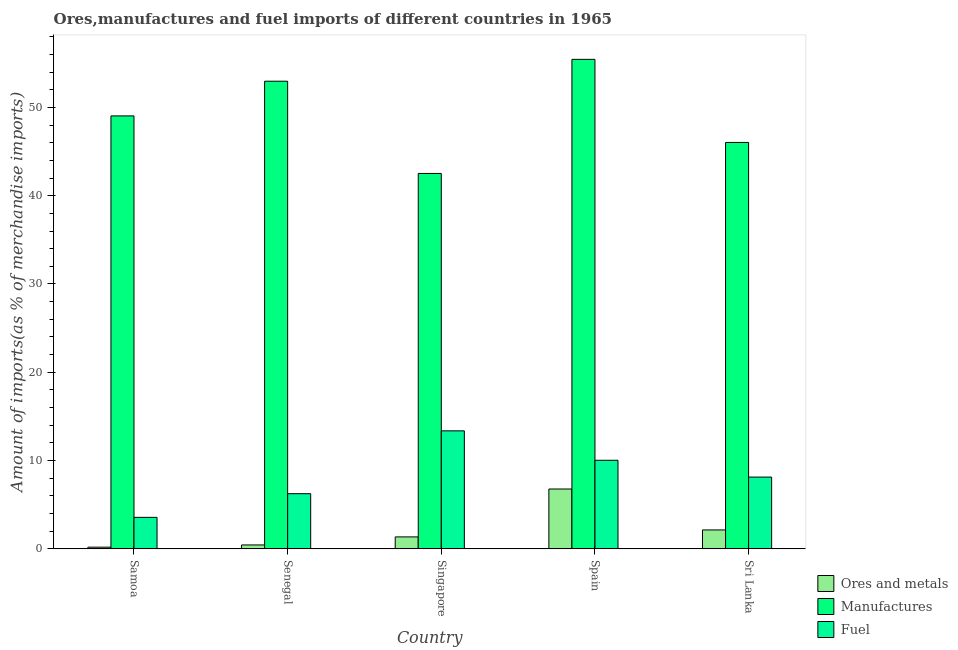How many groups of bars are there?
Provide a short and direct response. 5. Are the number of bars per tick equal to the number of legend labels?
Provide a succinct answer. Yes. How many bars are there on the 1st tick from the left?
Your answer should be compact. 3. How many bars are there on the 4th tick from the right?
Offer a very short reply. 3. What is the label of the 3rd group of bars from the left?
Provide a short and direct response. Singapore. In how many cases, is the number of bars for a given country not equal to the number of legend labels?
Ensure brevity in your answer.  0. What is the percentage of fuel imports in Singapore?
Your response must be concise. 13.37. Across all countries, what is the maximum percentage of ores and metals imports?
Keep it short and to the point. 6.78. Across all countries, what is the minimum percentage of ores and metals imports?
Your answer should be very brief. 0.19. In which country was the percentage of fuel imports maximum?
Provide a succinct answer. Singapore. In which country was the percentage of ores and metals imports minimum?
Your answer should be very brief. Samoa. What is the total percentage of manufactures imports in the graph?
Your response must be concise. 246.01. What is the difference between the percentage of manufactures imports in Spain and that in Sri Lanka?
Your answer should be very brief. 9.41. What is the difference between the percentage of manufactures imports in Senegal and the percentage of fuel imports in Spain?
Keep it short and to the point. 42.94. What is the average percentage of manufactures imports per country?
Offer a very short reply. 49.2. What is the difference between the percentage of fuel imports and percentage of ores and metals imports in Sri Lanka?
Give a very brief answer. 5.99. In how many countries, is the percentage of manufactures imports greater than 42 %?
Offer a very short reply. 5. What is the ratio of the percentage of ores and metals imports in Samoa to that in Senegal?
Keep it short and to the point. 0.43. Is the percentage of fuel imports in Samoa less than that in Spain?
Your response must be concise. Yes. What is the difference between the highest and the second highest percentage of fuel imports?
Your answer should be very brief. 3.33. What is the difference between the highest and the lowest percentage of manufactures imports?
Your answer should be very brief. 12.92. What does the 3rd bar from the left in Singapore represents?
Ensure brevity in your answer.  Fuel. What does the 1st bar from the right in Sri Lanka represents?
Keep it short and to the point. Fuel. Is it the case that in every country, the sum of the percentage of ores and metals imports and percentage of manufactures imports is greater than the percentage of fuel imports?
Give a very brief answer. Yes. What is the difference between two consecutive major ticks on the Y-axis?
Offer a very short reply. 10. Are the values on the major ticks of Y-axis written in scientific E-notation?
Offer a terse response. No. Does the graph contain any zero values?
Your response must be concise. No. Does the graph contain grids?
Offer a terse response. No. How are the legend labels stacked?
Ensure brevity in your answer.  Vertical. What is the title of the graph?
Provide a short and direct response. Ores,manufactures and fuel imports of different countries in 1965. What is the label or title of the Y-axis?
Offer a very short reply. Amount of imports(as % of merchandise imports). What is the Amount of imports(as % of merchandise imports) of Ores and metals in Samoa?
Offer a terse response. 0.19. What is the Amount of imports(as % of merchandise imports) of Manufactures in Samoa?
Ensure brevity in your answer.  49.04. What is the Amount of imports(as % of merchandise imports) in Fuel in Samoa?
Your answer should be compact. 3.57. What is the Amount of imports(as % of merchandise imports) in Ores and metals in Senegal?
Provide a short and direct response. 0.44. What is the Amount of imports(as % of merchandise imports) in Manufactures in Senegal?
Provide a succinct answer. 52.97. What is the Amount of imports(as % of merchandise imports) in Fuel in Senegal?
Your answer should be very brief. 6.25. What is the Amount of imports(as % of merchandise imports) of Ores and metals in Singapore?
Offer a very short reply. 1.35. What is the Amount of imports(as % of merchandise imports) of Manufactures in Singapore?
Your response must be concise. 42.52. What is the Amount of imports(as % of merchandise imports) of Fuel in Singapore?
Your response must be concise. 13.37. What is the Amount of imports(as % of merchandise imports) in Ores and metals in Spain?
Your answer should be very brief. 6.78. What is the Amount of imports(as % of merchandise imports) of Manufactures in Spain?
Ensure brevity in your answer.  55.44. What is the Amount of imports(as % of merchandise imports) of Fuel in Spain?
Provide a short and direct response. 10.03. What is the Amount of imports(as % of merchandise imports) of Ores and metals in Sri Lanka?
Provide a short and direct response. 2.14. What is the Amount of imports(as % of merchandise imports) of Manufactures in Sri Lanka?
Offer a terse response. 46.03. What is the Amount of imports(as % of merchandise imports) in Fuel in Sri Lanka?
Keep it short and to the point. 8.13. Across all countries, what is the maximum Amount of imports(as % of merchandise imports) of Ores and metals?
Make the answer very short. 6.78. Across all countries, what is the maximum Amount of imports(as % of merchandise imports) of Manufactures?
Offer a terse response. 55.44. Across all countries, what is the maximum Amount of imports(as % of merchandise imports) in Fuel?
Keep it short and to the point. 13.37. Across all countries, what is the minimum Amount of imports(as % of merchandise imports) in Ores and metals?
Ensure brevity in your answer.  0.19. Across all countries, what is the minimum Amount of imports(as % of merchandise imports) in Manufactures?
Your answer should be very brief. 42.52. Across all countries, what is the minimum Amount of imports(as % of merchandise imports) of Fuel?
Give a very brief answer. 3.57. What is the total Amount of imports(as % of merchandise imports) in Ores and metals in the graph?
Offer a very short reply. 10.91. What is the total Amount of imports(as % of merchandise imports) of Manufactures in the graph?
Your response must be concise. 246.01. What is the total Amount of imports(as % of merchandise imports) in Fuel in the graph?
Your answer should be compact. 41.34. What is the difference between the Amount of imports(as % of merchandise imports) of Ores and metals in Samoa and that in Senegal?
Your response must be concise. -0.25. What is the difference between the Amount of imports(as % of merchandise imports) of Manufactures in Samoa and that in Senegal?
Make the answer very short. -3.93. What is the difference between the Amount of imports(as % of merchandise imports) of Fuel in Samoa and that in Senegal?
Offer a terse response. -2.68. What is the difference between the Amount of imports(as % of merchandise imports) of Ores and metals in Samoa and that in Singapore?
Give a very brief answer. -1.16. What is the difference between the Amount of imports(as % of merchandise imports) of Manufactures in Samoa and that in Singapore?
Provide a short and direct response. 6.52. What is the difference between the Amount of imports(as % of merchandise imports) of Fuel in Samoa and that in Singapore?
Keep it short and to the point. -9.8. What is the difference between the Amount of imports(as % of merchandise imports) of Ores and metals in Samoa and that in Spain?
Your answer should be very brief. -6.59. What is the difference between the Amount of imports(as % of merchandise imports) in Manufactures in Samoa and that in Spain?
Keep it short and to the point. -6.41. What is the difference between the Amount of imports(as % of merchandise imports) of Fuel in Samoa and that in Spain?
Ensure brevity in your answer.  -6.46. What is the difference between the Amount of imports(as % of merchandise imports) in Ores and metals in Samoa and that in Sri Lanka?
Your answer should be compact. -1.95. What is the difference between the Amount of imports(as % of merchandise imports) of Manufactures in Samoa and that in Sri Lanka?
Keep it short and to the point. 3.01. What is the difference between the Amount of imports(as % of merchandise imports) of Fuel in Samoa and that in Sri Lanka?
Offer a terse response. -4.56. What is the difference between the Amount of imports(as % of merchandise imports) in Ores and metals in Senegal and that in Singapore?
Offer a terse response. -0.91. What is the difference between the Amount of imports(as % of merchandise imports) in Manufactures in Senegal and that in Singapore?
Offer a terse response. 10.45. What is the difference between the Amount of imports(as % of merchandise imports) in Fuel in Senegal and that in Singapore?
Offer a very short reply. -7.12. What is the difference between the Amount of imports(as % of merchandise imports) of Ores and metals in Senegal and that in Spain?
Offer a very short reply. -6.34. What is the difference between the Amount of imports(as % of merchandise imports) of Manufactures in Senegal and that in Spain?
Make the answer very short. -2.48. What is the difference between the Amount of imports(as % of merchandise imports) in Fuel in Senegal and that in Spain?
Make the answer very short. -3.79. What is the difference between the Amount of imports(as % of merchandise imports) in Ores and metals in Senegal and that in Sri Lanka?
Make the answer very short. -1.7. What is the difference between the Amount of imports(as % of merchandise imports) in Manufactures in Senegal and that in Sri Lanka?
Provide a short and direct response. 6.94. What is the difference between the Amount of imports(as % of merchandise imports) of Fuel in Senegal and that in Sri Lanka?
Ensure brevity in your answer.  -1.88. What is the difference between the Amount of imports(as % of merchandise imports) in Ores and metals in Singapore and that in Spain?
Your answer should be very brief. -5.42. What is the difference between the Amount of imports(as % of merchandise imports) in Manufactures in Singapore and that in Spain?
Offer a terse response. -12.92. What is the difference between the Amount of imports(as % of merchandise imports) of Fuel in Singapore and that in Spain?
Give a very brief answer. 3.33. What is the difference between the Amount of imports(as % of merchandise imports) in Ores and metals in Singapore and that in Sri Lanka?
Keep it short and to the point. -0.79. What is the difference between the Amount of imports(as % of merchandise imports) in Manufactures in Singapore and that in Sri Lanka?
Your answer should be compact. -3.51. What is the difference between the Amount of imports(as % of merchandise imports) in Fuel in Singapore and that in Sri Lanka?
Provide a succinct answer. 5.24. What is the difference between the Amount of imports(as % of merchandise imports) in Ores and metals in Spain and that in Sri Lanka?
Make the answer very short. 4.64. What is the difference between the Amount of imports(as % of merchandise imports) in Manufactures in Spain and that in Sri Lanka?
Provide a short and direct response. 9.41. What is the difference between the Amount of imports(as % of merchandise imports) in Fuel in Spain and that in Sri Lanka?
Provide a succinct answer. 1.9. What is the difference between the Amount of imports(as % of merchandise imports) in Ores and metals in Samoa and the Amount of imports(as % of merchandise imports) in Manufactures in Senegal?
Your answer should be very brief. -52.78. What is the difference between the Amount of imports(as % of merchandise imports) in Ores and metals in Samoa and the Amount of imports(as % of merchandise imports) in Fuel in Senegal?
Your answer should be very brief. -6.06. What is the difference between the Amount of imports(as % of merchandise imports) in Manufactures in Samoa and the Amount of imports(as % of merchandise imports) in Fuel in Senegal?
Your response must be concise. 42.79. What is the difference between the Amount of imports(as % of merchandise imports) in Ores and metals in Samoa and the Amount of imports(as % of merchandise imports) in Manufactures in Singapore?
Make the answer very short. -42.33. What is the difference between the Amount of imports(as % of merchandise imports) in Ores and metals in Samoa and the Amount of imports(as % of merchandise imports) in Fuel in Singapore?
Ensure brevity in your answer.  -13.17. What is the difference between the Amount of imports(as % of merchandise imports) of Manufactures in Samoa and the Amount of imports(as % of merchandise imports) of Fuel in Singapore?
Offer a terse response. 35.67. What is the difference between the Amount of imports(as % of merchandise imports) in Ores and metals in Samoa and the Amount of imports(as % of merchandise imports) in Manufactures in Spain?
Keep it short and to the point. -55.25. What is the difference between the Amount of imports(as % of merchandise imports) in Ores and metals in Samoa and the Amount of imports(as % of merchandise imports) in Fuel in Spain?
Give a very brief answer. -9.84. What is the difference between the Amount of imports(as % of merchandise imports) of Manufactures in Samoa and the Amount of imports(as % of merchandise imports) of Fuel in Spain?
Keep it short and to the point. 39.01. What is the difference between the Amount of imports(as % of merchandise imports) in Ores and metals in Samoa and the Amount of imports(as % of merchandise imports) in Manufactures in Sri Lanka?
Make the answer very short. -45.84. What is the difference between the Amount of imports(as % of merchandise imports) of Ores and metals in Samoa and the Amount of imports(as % of merchandise imports) of Fuel in Sri Lanka?
Provide a succinct answer. -7.94. What is the difference between the Amount of imports(as % of merchandise imports) of Manufactures in Samoa and the Amount of imports(as % of merchandise imports) of Fuel in Sri Lanka?
Give a very brief answer. 40.91. What is the difference between the Amount of imports(as % of merchandise imports) in Ores and metals in Senegal and the Amount of imports(as % of merchandise imports) in Manufactures in Singapore?
Your answer should be very brief. -42.08. What is the difference between the Amount of imports(as % of merchandise imports) of Ores and metals in Senegal and the Amount of imports(as % of merchandise imports) of Fuel in Singapore?
Your response must be concise. -12.92. What is the difference between the Amount of imports(as % of merchandise imports) in Manufactures in Senegal and the Amount of imports(as % of merchandise imports) in Fuel in Singapore?
Your response must be concise. 39.6. What is the difference between the Amount of imports(as % of merchandise imports) in Ores and metals in Senegal and the Amount of imports(as % of merchandise imports) in Manufactures in Spain?
Offer a very short reply. -55. What is the difference between the Amount of imports(as % of merchandise imports) of Ores and metals in Senegal and the Amount of imports(as % of merchandise imports) of Fuel in Spain?
Offer a very short reply. -9.59. What is the difference between the Amount of imports(as % of merchandise imports) of Manufactures in Senegal and the Amount of imports(as % of merchandise imports) of Fuel in Spain?
Your answer should be very brief. 42.94. What is the difference between the Amount of imports(as % of merchandise imports) of Ores and metals in Senegal and the Amount of imports(as % of merchandise imports) of Manufactures in Sri Lanka?
Provide a succinct answer. -45.59. What is the difference between the Amount of imports(as % of merchandise imports) of Ores and metals in Senegal and the Amount of imports(as % of merchandise imports) of Fuel in Sri Lanka?
Offer a terse response. -7.69. What is the difference between the Amount of imports(as % of merchandise imports) in Manufactures in Senegal and the Amount of imports(as % of merchandise imports) in Fuel in Sri Lanka?
Your response must be concise. 44.84. What is the difference between the Amount of imports(as % of merchandise imports) in Ores and metals in Singapore and the Amount of imports(as % of merchandise imports) in Manufactures in Spain?
Keep it short and to the point. -54.09. What is the difference between the Amount of imports(as % of merchandise imports) in Ores and metals in Singapore and the Amount of imports(as % of merchandise imports) in Fuel in Spain?
Keep it short and to the point. -8.68. What is the difference between the Amount of imports(as % of merchandise imports) in Manufactures in Singapore and the Amount of imports(as % of merchandise imports) in Fuel in Spain?
Provide a succinct answer. 32.49. What is the difference between the Amount of imports(as % of merchandise imports) in Ores and metals in Singapore and the Amount of imports(as % of merchandise imports) in Manufactures in Sri Lanka?
Offer a very short reply. -44.68. What is the difference between the Amount of imports(as % of merchandise imports) in Ores and metals in Singapore and the Amount of imports(as % of merchandise imports) in Fuel in Sri Lanka?
Keep it short and to the point. -6.77. What is the difference between the Amount of imports(as % of merchandise imports) of Manufactures in Singapore and the Amount of imports(as % of merchandise imports) of Fuel in Sri Lanka?
Offer a terse response. 34.39. What is the difference between the Amount of imports(as % of merchandise imports) in Ores and metals in Spain and the Amount of imports(as % of merchandise imports) in Manufactures in Sri Lanka?
Provide a short and direct response. -39.25. What is the difference between the Amount of imports(as % of merchandise imports) of Ores and metals in Spain and the Amount of imports(as % of merchandise imports) of Fuel in Sri Lanka?
Your answer should be very brief. -1.35. What is the difference between the Amount of imports(as % of merchandise imports) in Manufactures in Spain and the Amount of imports(as % of merchandise imports) in Fuel in Sri Lanka?
Your answer should be compact. 47.32. What is the average Amount of imports(as % of merchandise imports) of Ores and metals per country?
Offer a terse response. 2.18. What is the average Amount of imports(as % of merchandise imports) in Manufactures per country?
Give a very brief answer. 49.2. What is the average Amount of imports(as % of merchandise imports) in Fuel per country?
Offer a terse response. 8.27. What is the difference between the Amount of imports(as % of merchandise imports) of Ores and metals and Amount of imports(as % of merchandise imports) of Manufactures in Samoa?
Offer a terse response. -48.85. What is the difference between the Amount of imports(as % of merchandise imports) of Ores and metals and Amount of imports(as % of merchandise imports) of Fuel in Samoa?
Keep it short and to the point. -3.38. What is the difference between the Amount of imports(as % of merchandise imports) of Manufactures and Amount of imports(as % of merchandise imports) of Fuel in Samoa?
Your answer should be very brief. 45.47. What is the difference between the Amount of imports(as % of merchandise imports) of Ores and metals and Amount of imports(as % of merchandise imports) of Manufactures in Senegal?
Ensure brevity in your answer.  -52.53. What is the difference between the Amount of imports(as % of merchandise imports) in Ores and metals and Amount of imports(as % of merchandise imports) in Fuel in Senegal?
Keep it short and to the point. -5.81. What is the difference between the Amount of imports(as % of merchandise imports) of Manufactures and Amount of imports(as % of merchandise imports) of Fuel in Senegal?
Your answer should be compact. 46.72. What is the difference between the Amount of imports(as % of merchandise imports) in Ores and metals and Amount of imports(as % of merchandise imports) in Manufactures in Singapore?
Keep it short and to the point. -41.17. What is the difference between the Amount of imports(as % of merchandise imports) of Ores and metals and Amount of imports(as % of merchandise imports) of Fuel in Singapore?
Your answer should be compact. -12.01. What is the difference between the Amount of imports(as % of merchandise imports) in Manufactures and Amount of imports(as % of merchandise imports) in Fuel in Singapore?
Give a very brief answer. 29.16. What is the difference between the Amount of imports(as % of merchandise imports) in Ores and metals and Amount of imports(as % of merchandise imports) in Manufactures in Spain?
Ensure brevity in your answer.  -48.67. What is the difference between the Amount of imports(as % of merchandise imports) in Ores and metals and Amount of imports(as % of merchandise imports) in Fuel in Spain?
Offer a terse response. -3.25. What is the difference between the Amount of imports(as % of merchandise imports) of Manufactures and Amount of imports(as % of merchandise imports) of Fuel in Spain?
Keep it short and to the point. 45.41. What is the difference between the Amount of imports(as % of merchandise imports) of Ores and metals and Amount of imports(as % of merchandise imports) of Manufactures in Sri Lanka?
Your answer should be compact. -43.89. What is the difference between the Amount of imports(as % of merchandise imports) in Ores and metals and Amount of imports(as % of merchandise imports) in Fuel in Sri Lanka?
Keep it short and to the point. -5.99. What is the difference between the Amount of imports(as % of merchandise imports) of Manufactures and Amount of imports(as % of merchandise imports) of Fuel in Sri Lanka?
Your answer should be compact. 37.9. What is the ratio of the Amount of imports(as % of merchandise imports) in Ores and metals in Samoa to that in Senegal?
Offer a terse response. 0.43. What is the ratio of the Amount of imports(as % of merchandise imports) in Manufactures in Samoa to that in Senegal?
Ensure brevity in your answer.  0.93. What is the ratio of the Amount of imports(as % of merchandise imports) of Fuel in Samoa to that in Senegal?
Your answer should be very brief. 0.57. What is the ratio of the Amount of imports(as % of merchandise imports) in Ores and metals in Samoa to that in Singapore?
Your response must be concise. 0.14. What is the ratio of the Amount of imports(as % of merchandise imports) of Manufactures in Samoa to that in Singapore?
Offer a terse response. 1.15. What is the ratio of the Amount of imports(as % of merchandise imports) in Fuel in Samoa to that in Singapore?
Your answer should be very brief. 0.27. What is the ratio of the Amount of imports(as % of merchandise imports) of Ores and metals in Samoa to that in Spain?
Offer a very short reply. 0.03. What is the ratio of the Amount of imports(as % of merchandise imports) of Manufactures in Samoa to that in Spain?
Keep it short and to the point. 0.88. What is the ratio of the Amount of imports(as % of merchandise imports) of Fuel in Samoa to that in Spain?
Make the answer very short. 0.36. What is the ratio of the Amount of imports(as % of merchandise imports) of Ores and metals in Samoa to that in Sri Lanka?
Give a very brief answer. 0.09. What is the ratio of the Amount of imports(as % of merchandise imports) of Manufactures in Samoa to that in Sri Lanka?
Make the answer very short. 1.07. What is the ratio of the Amount of imports(as % of merchandise imports) in Fuel in Samoa to that in Sri Lanka?
Offer a very short reply. 0.44. What is the ratio of the Amount of imports(as % of merchandise imports) of Ores and metals in Senegal to that in Singapore?
Offer a terse response. 0.33. What is the ratio of the Amount of imports(as % of merchandise imports) in Manufactures in Senegal to that in Singapore?
Provide a succinct answer. 1.25. What is the ratio of the Amount of imports(as % of merchandise imports) in Fuel in Senegal to that in Singapore?
Provide a short and direct response. 0.47. What is the ratio of the Amount of imports(as % of merchandise imports) of Ores and metals in Senegal to that in Spain?
Offer a terse response. 0.07. What is the ratio of the Amount of imports(as % of merchandise imports) in Manufactures in Senegal to that in Spain?
Make the answer very short. 0.96. What is the ratio of the Amount of imports(as % of merchandise imports) of Fuel in Senegal to that in Spain?
Your response must be concise. 0.62. What is the ratio of the Amount of imports(as % of merchandise imports) in Ores and metals in Senegal to that in Sri Lanka?
Your answer should be compact. 0.21. What is the ratio of the Amount of imports(as % of merchandise imports) of Manufactures in Senegal to that in Sri Lanka?
Keep it short and to the point. 1.15. What is the ratio of the Amount of imports(as % of merchandise imports) in Fuel in Senegal to that in Sri Lanka?
Your answer should be very brief. 0.77. What is the ratio of the Amount of imports(as % of merchandise imports) of Ores and metals in Singapore to that in Spain?
Make the answer very short. 0.2. What is the ratio of the Amount of imports(as % of merchandise imports) in Manufactures in Singapore to that in Spain?
Keep it short and to the point. 0.77. What is the ratio of the Amount of imports(as % of merchandise imports) of Fuel in Singapore to that in Spain?
Offer a very short reply. 1.33. What is the ratio of the Amount of imports(as % of merchandise imports) of Ores and metals in Singapore to that in Sri Lanka?
Your response must be concise. 0.63. What is the ratio of the Amount of imports(as % of merchandise imports) of Manufactures in Singapore to that in Sri Lanka?
Give a very brief answer. 0.92. What is the ratio of the Amount of imports(as % of merchandise imports) in Fuel in Singapore to that in Sri Lanka?
Your answer should be very brief. 1.64. What is the ratio of the Amount of imports(as % of merchandise imports) of Ores and metals in Spain to that in Sri Lanka?
Your answer should be very brief. 3.16. What is the ratio of the Amount of imports(as % of merchandise imports) of Manufactures in Spain to that in Sri Lanka?
Make the answer very short. 1.2. What is the ratio of the Amount of imports(as % of merchandise imports) in Fuel in Spain to that in Sri Lanka?
Make the answer very short. 1.23. What is the difference between the highest and the second highest Amount of imports(as % of merchandise imports) in Ores and metals?
Provide a short and direct response. 4.64. What is the difference between the highest and the second highest Amount of imports(as % of merchandise imports) of Manufactures?
Make the answer very short. 2.48. What is the difference between the highest and the second highest Amount of imports(as % of merchandise imports) of Fuel?
Offer a very short reply. 3.33. What is the difference between the highest and the lowest Amount of imports(as % of merchandise imports) in Ores and metals?
Your response must be concise. 6.59. What is the difference between the highest and the lowest Amount of imports(as % of merchandise imports) of Manufactures?
Provide a succinct answer. 12.92. What is the difference between the highest and the lowest Amount of imports(as % of merchandise imports) in Fuel?
Give a very brief answer. 9.8. 